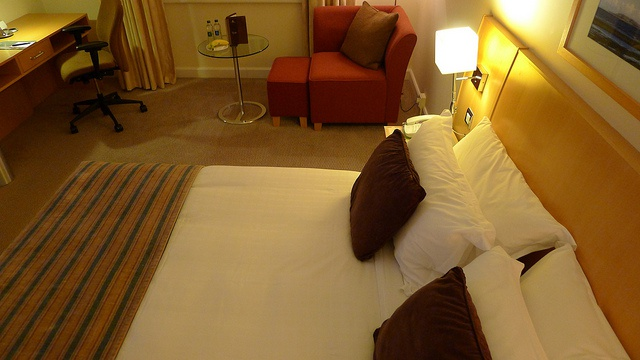Describe the objects in this image and their specific colors. I can see bed in olive, tan, maroon, and black tones, chair in olive, maroon, black, and brown tones, chair in olive, black, and maroon tones, dining table in olive, maroon, and black tones, and book in olive, black, and maroon tones in this image. 